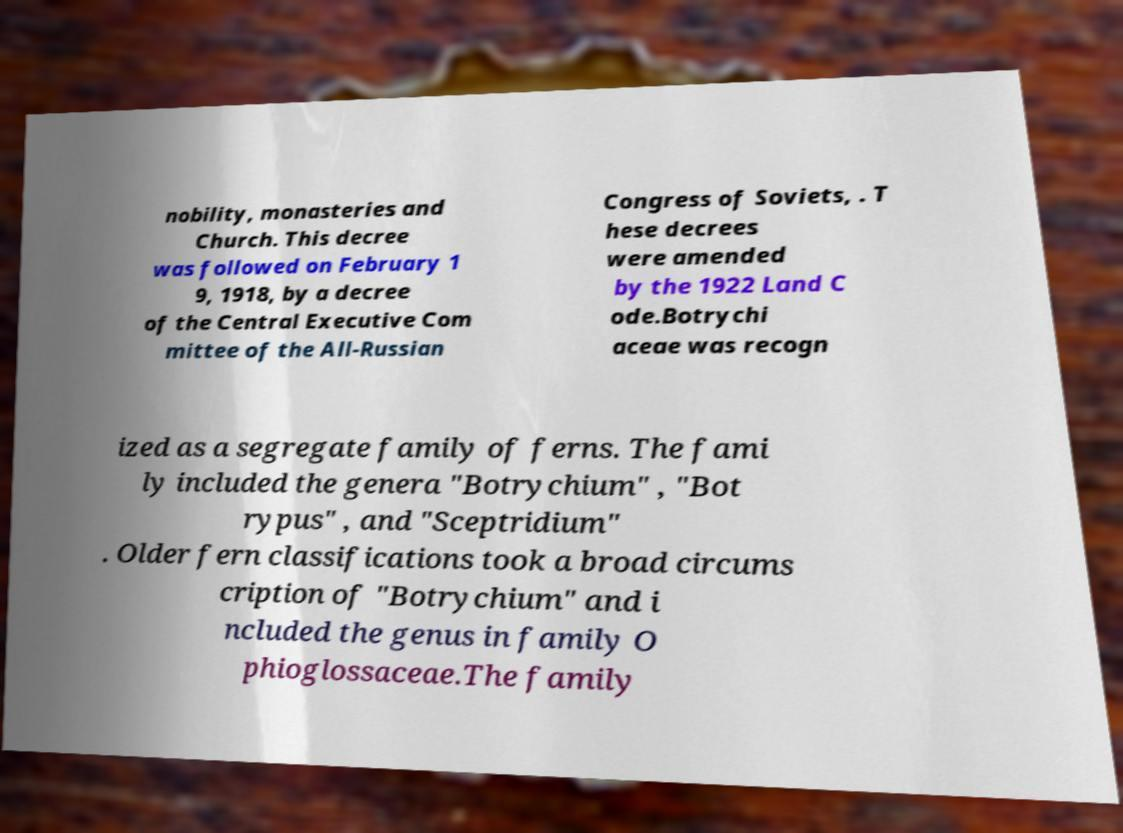For documentation purposes, I need the text within this image transcribed. Could you provide that? nobility, monasteries and Church. This decree was followed on February 1 9, 1918, by a decree of the Central Executive Com mittee of the All-Russian Congress of Soviets, . T hese decrees were amended by the 1922 Land C ode.Botrychi aceae was recogn ized as a segregate family of ferns. The fami ly included the genera "Botrychium" , "Bot rypus" , and "Sceptridium" . Older fern classifications took a broad circums cription of "Botrychium" and i ncluded the genus in family O phioglossaceae.The family 